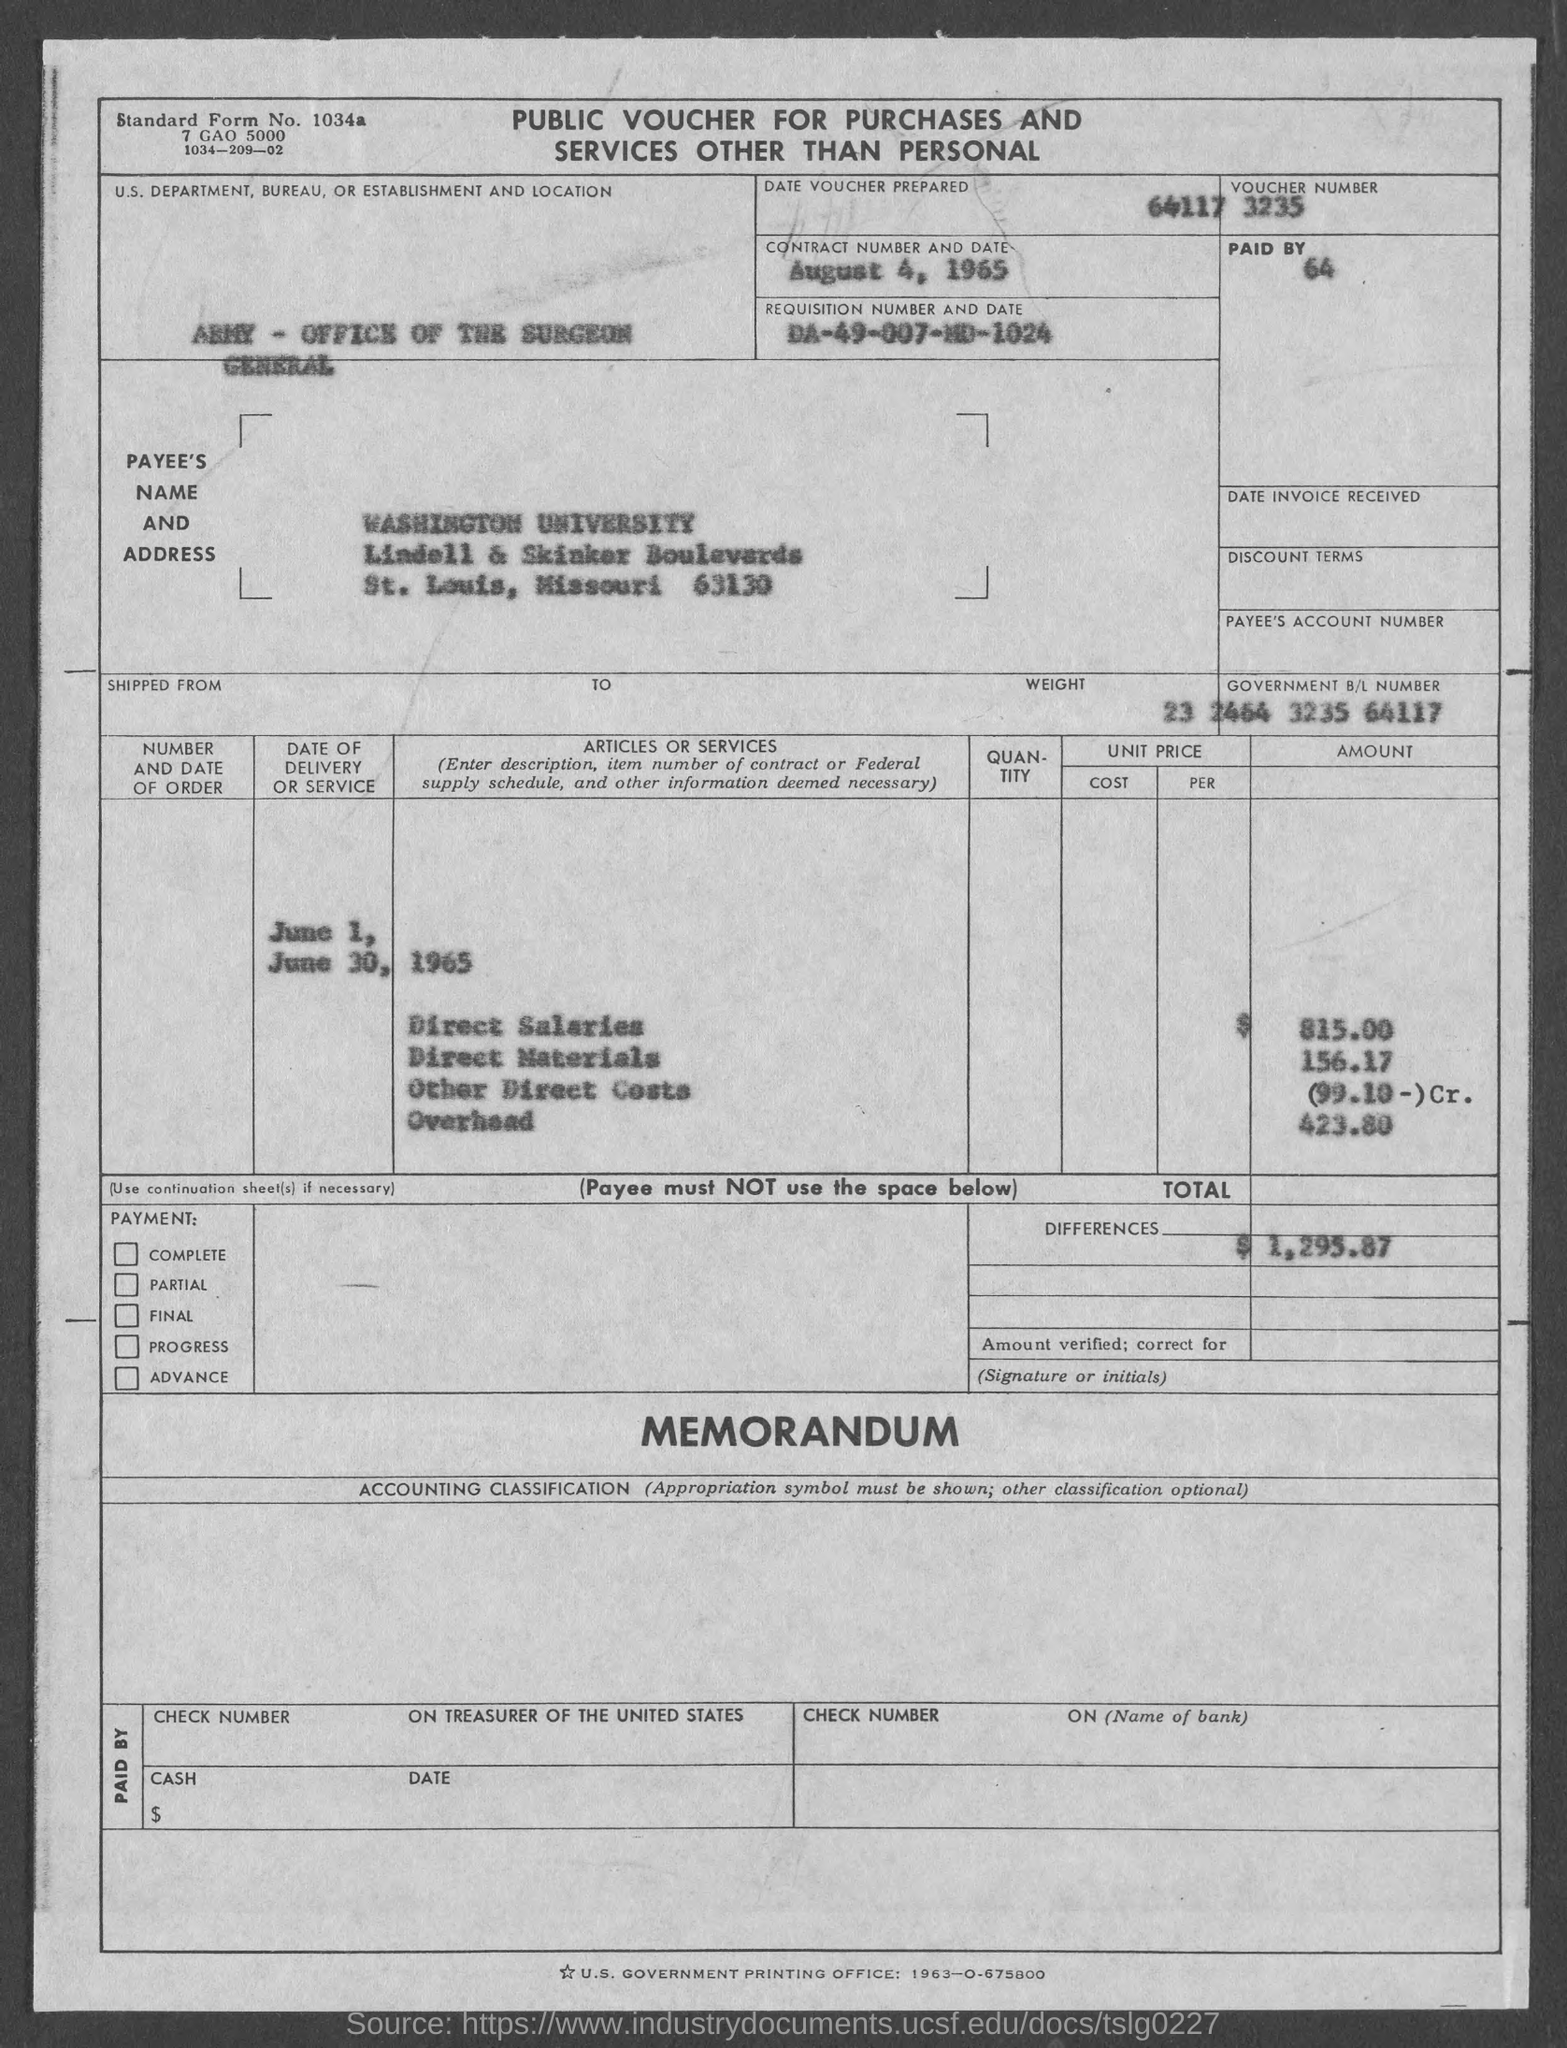What is the requisition number and date as mentioned in the given page ?
Ensure brevity in your answer.  DA-49-007-MD-1024. What is the name of department ,bureau or establishment as mentioned in the given page ?
Offer a terse response. Army- office of the surgeon general. What is the amount of direct salaries as mentioned in the given form ?
Ensure brevity in your answer.  815.00. What is the amount for direct materials as mentioned in the given form ?
Ensure brevity in your answer.  156.17. What is the amount of overhead as mentioned in the given form ?
Provide a short and direct response. 423.80. What is the total differences amount as mentioned in the given page ?
Offer a very short reply. $ 1,295.87. 